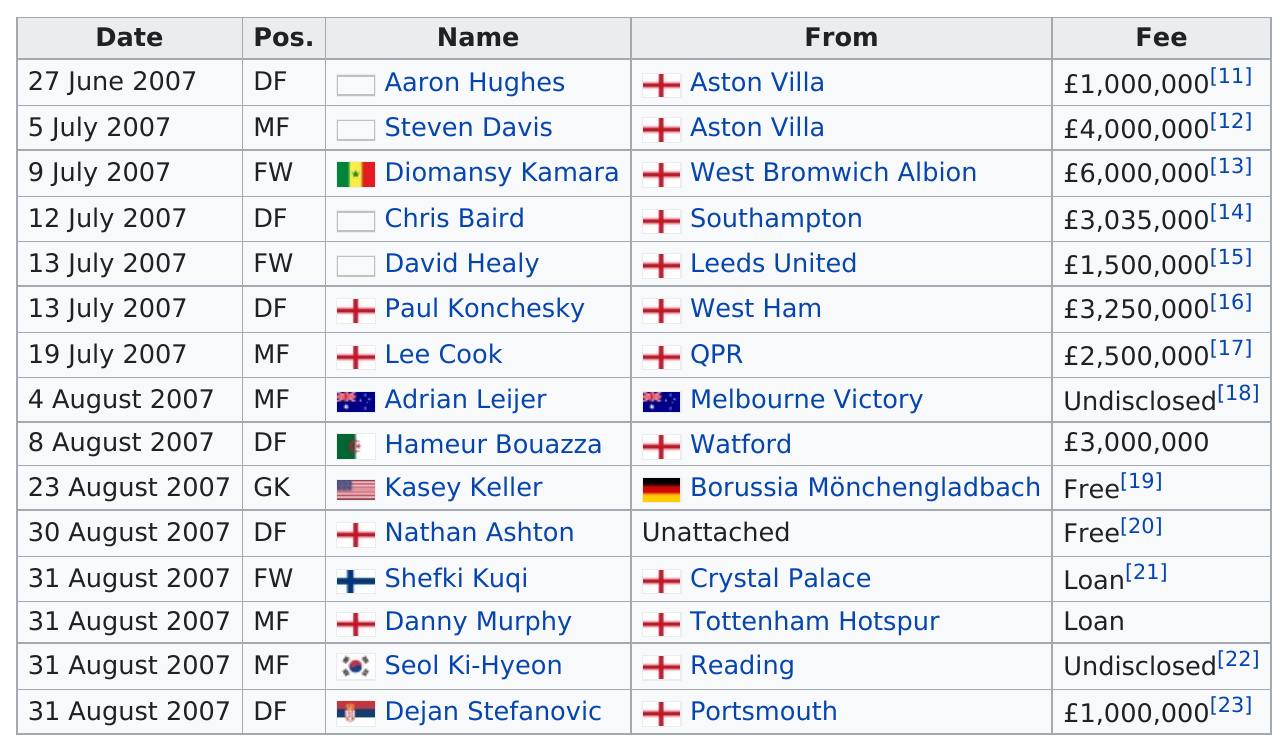Draw attention to some important aspects in this diagram. Adrian Leijer was the player who was transferred before Haméur Bouazza on August 8, 2007. The transfer with the highest disclosed amount of money paid during this season was worth a staggering £6,000,000. The number of depth-first search (DFS) for the given sequence is 6. The number of different positions represented is 4. The fee of Steven Davis was higher than that of Chris Baird. Steven Davis's fee was higher. 